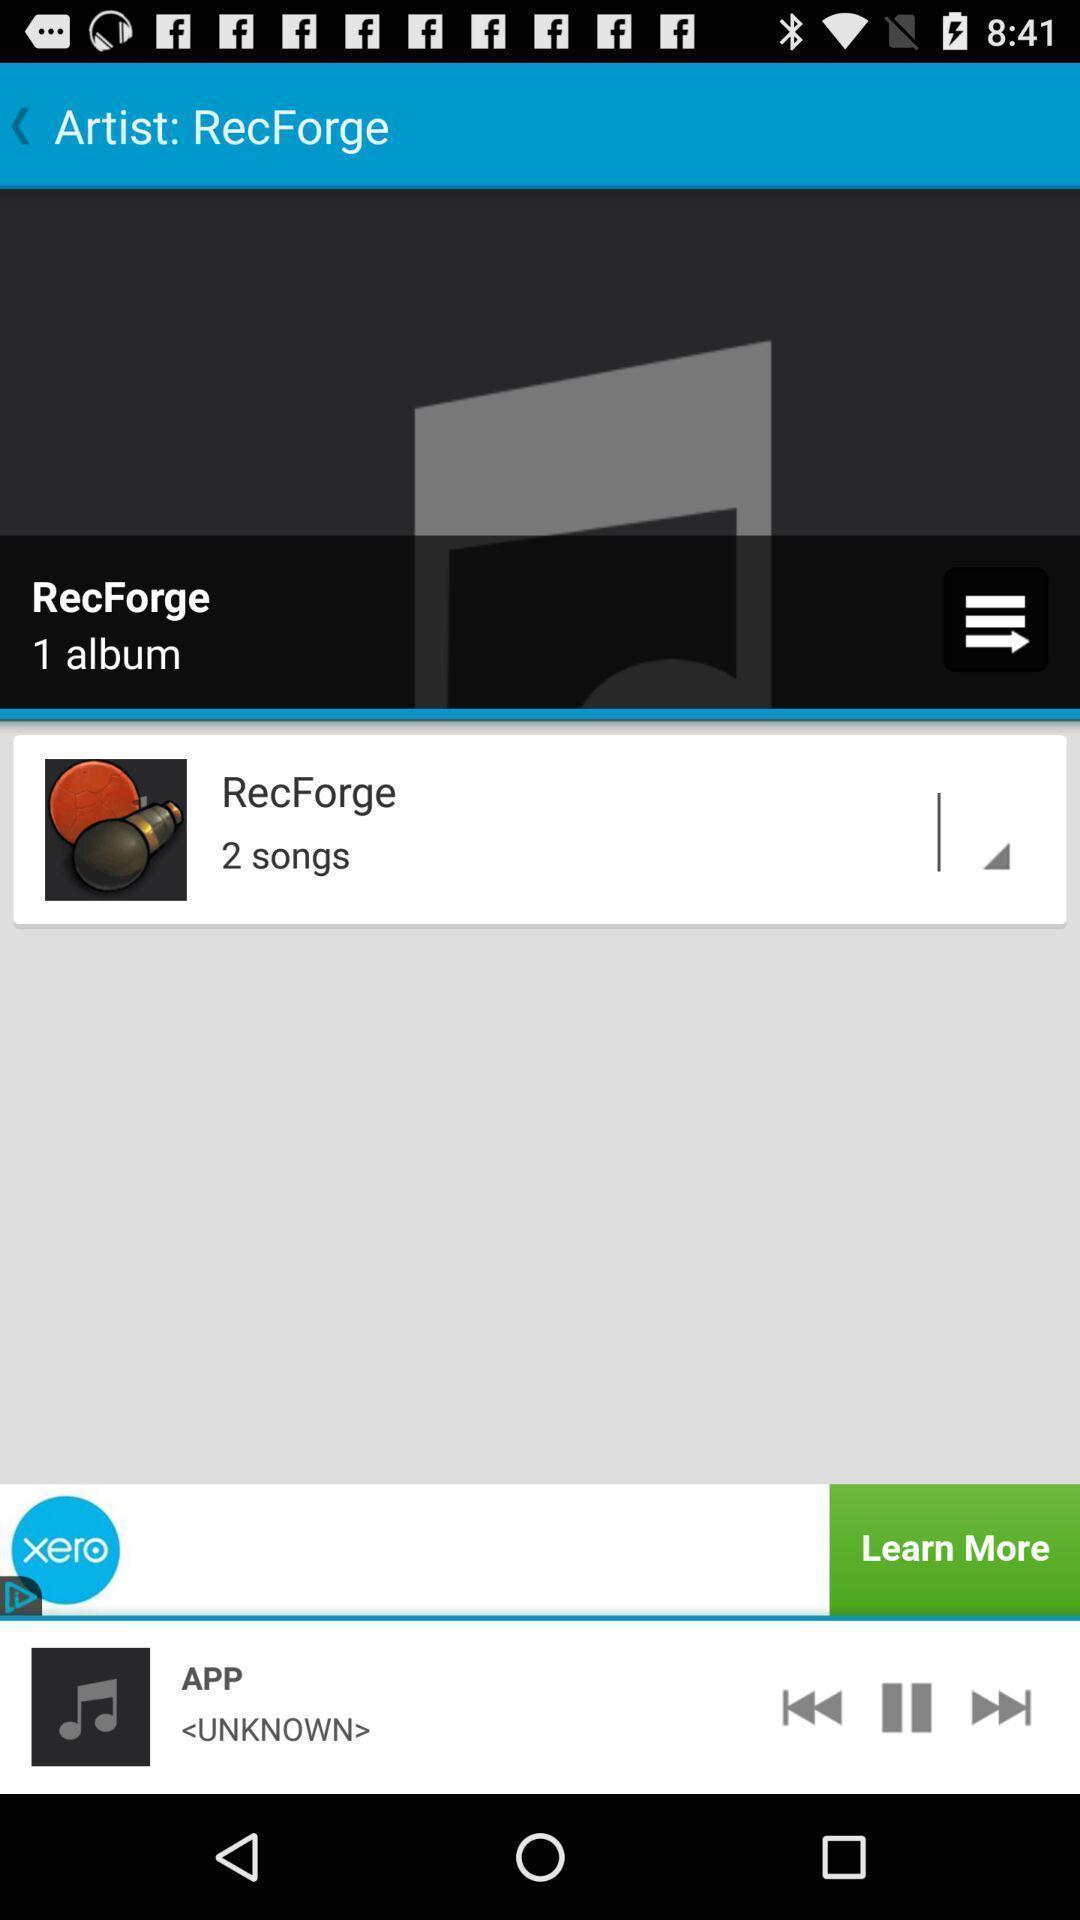What can you discern from this picture? Screen showing various icons like pause. 